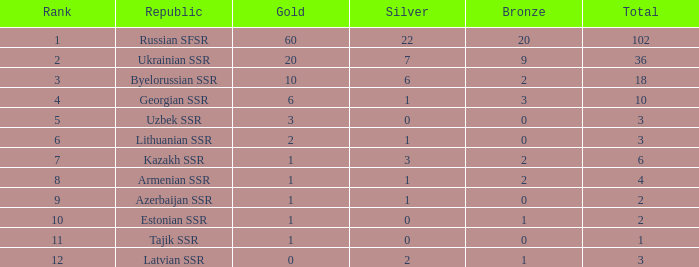What is the highest number of bronzes for teams ranked number 7 with more than 0 silver? 2.0. 